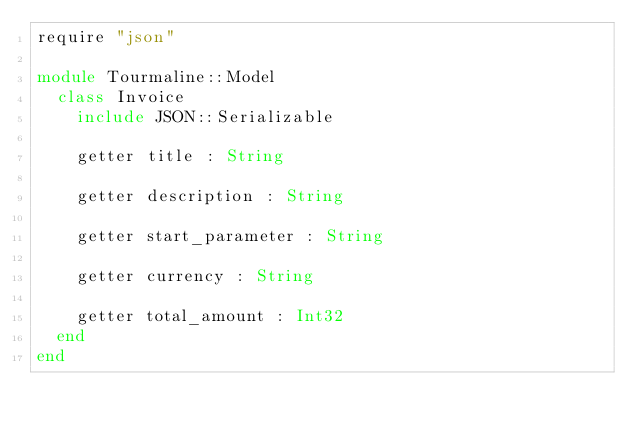<code> <loc_0><loc_0><loc_500><loc_500><_Crystal_>require "json"

module Tourmaline::Model
  class Invoice
    include JSON::Serializable

    getter title : String

    getter description : String

    getter start_parameter : String

    getter currency : String

    getter total_amount : Int32
  end
end
</code> 